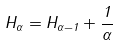<formula> <loc_0><loc_0><loc_500><loc_500>H _ { \alpha } = H _ { \alpha - 1 } + \frac { 1 } { \alpha }</formula> 